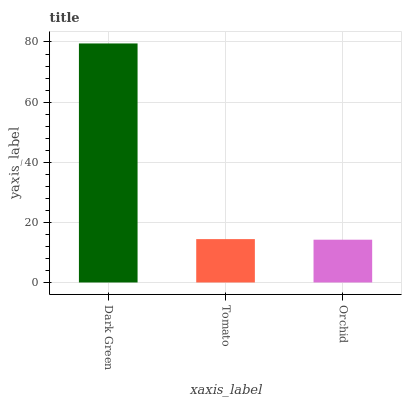Is Tomato the minimum?
Answer yes or no. No. Is Tomato the maximum?
Answer yes or no. No. Is Dark Green greater than Tomato?
Answer yes or no. Yes. Is Tomato less than Dark Green?
Answer yes or no. Yes. Is Tomato greater than Dark Green?
Answer yes or no. No. Is Dark Green less than Tomato?
Answer yes or no. No. Is Tomato the high median?
Answer yes or no. Yes. Is Tomato the low median?
Answer yes or no. Yes. Is Orchid the high median?
Answer yes or no. No. Is Orchid the low median?
Answer yes or no. No. 